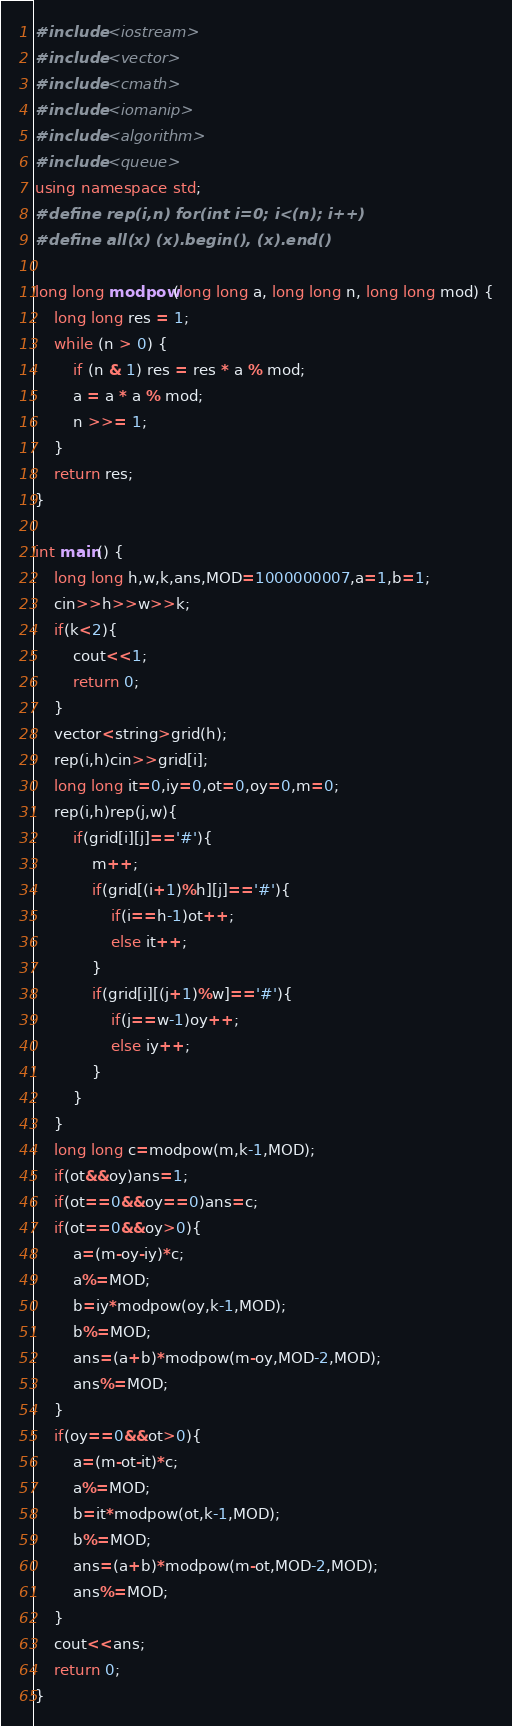<code> <loc_0><loc_0><loc_500><loc_500><_C++_>#include <iostream>
#include <vector>
#include <cmath>
#include <iomanip>
#include <algorithm>
#include <queue>
using namespace std;
#define rep(i,n) for(int i=0; i<(n); i++)
#define all(x) (x).begin(), (x).end()

long long modpow(long long a, long long n, long long mod) {
    long long res = 1;
    while (n > 0) {
        if (n & 1) res = res * a % mod;
        a = a * a % mod;
        n >>= 1;
    }
    return res;
}

int main() {
    long long h,w,k,ans,MOD=1000000007,a=1,b=1;
    cin>>h>>w>>k;
    if(k<2){
    	cout<<1;
    	return 0;
    }
    vector<string>grid(h);
    rep(i,h)cin>>grid[i];
    long long it=0,iy=0,ot=0,oy=0,m=0;
    rep(i,h)rep(j,w){
    	if(grid[i][j]=='#'){
    		m++;
    		if(grid[(i+1)%h][j]=='#'){
    			if(i==h-1)ot++;
    			else it++;
    		}
    		if(grid[i][(j+1)%w]=='#'){
    			if(j==w-1)oy++;
    			else iy++;
    		}
    	}
    }
    long long c=modpow(m,k-1,MOD);
    if(ot&&oy)ans=1;
    if(ot==0&&oy==0)ans=c;
    if(ot==0&&oy>0){
    	a=(m-oy-iy)*c;
    	a%=MOD;
    	b=iy*modpow(oy,k-1,MOD);
    	b%=MOD;
    	ans=(a+b)*modpow(m-oy,MOD-2,MOD);
    	ans%=MOD;
    }
    if(oy==0&&ot>0){
    	a=(m-ot-it)*c;
    	a%=MOD;
    	b=it*modpow(ot,k-1,MOD);
    	b%=MOD;
    	ans=(a+b)*modpow(m-ot,MOD-2,MOD);
    	ans%=MOD;
    }
    cout<<ans;
	return 0;
}
</code> 